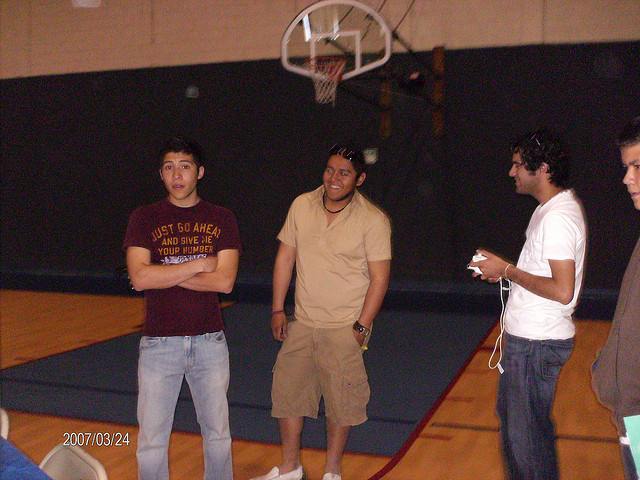Please identify all text content in this image. JUST AND 60 AHEAR AND GIVE IE 24 03I 2007 NUMBER YOUR 